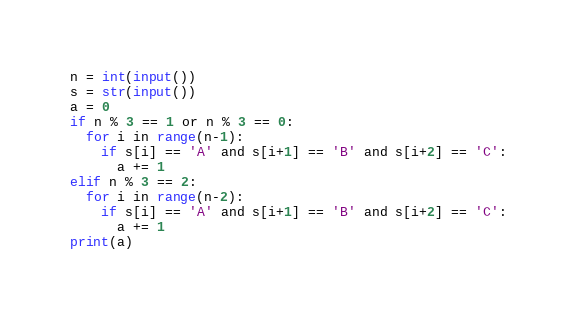Convert code to text. <code><loc_0><loc_0><loc_500><loc_500><_Python_>n = int(input())
s = str(input())
a = 0
if n % 3 == 1 or n % 3 == 0:
  for i in range(n-1):
    if s[i] == 'A' and s[i+1] == 'B' and s[i+2] == 'C':
      a += 1
elif n % 3 == 2:
  for i in range(n-2):
    if s[i] == 'A' and s[i+1] == 'B' and s[i+2] == 'C':
      a += 1
print(a)</code> 